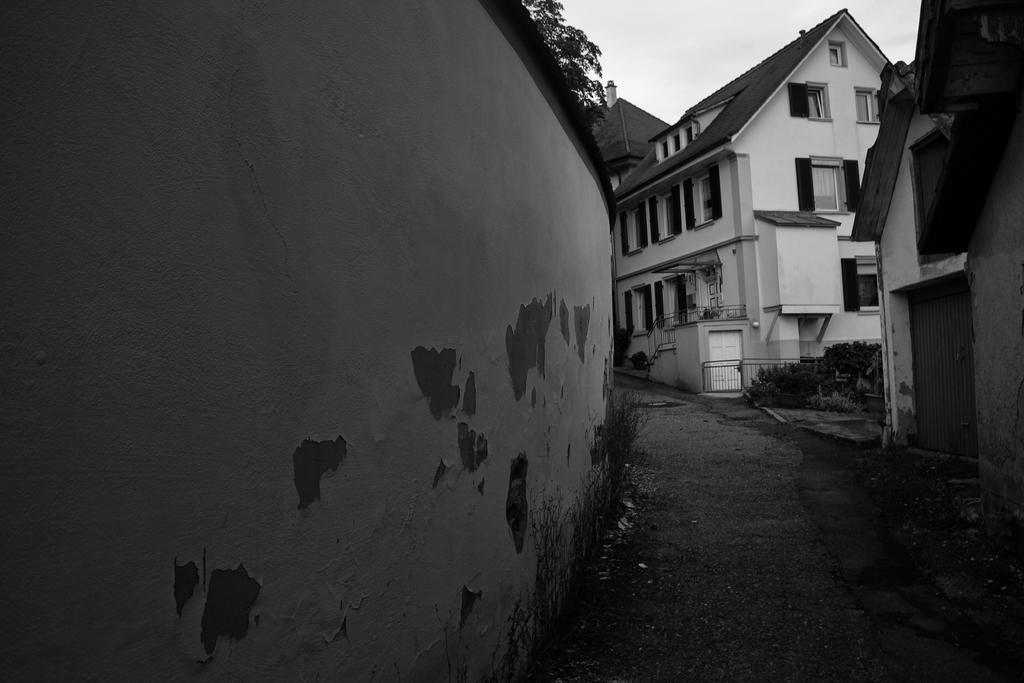Could you give a brief overview of what you see in this image? In this picture we can see wall, plants and houses. In the background of the image we can see the sky. 